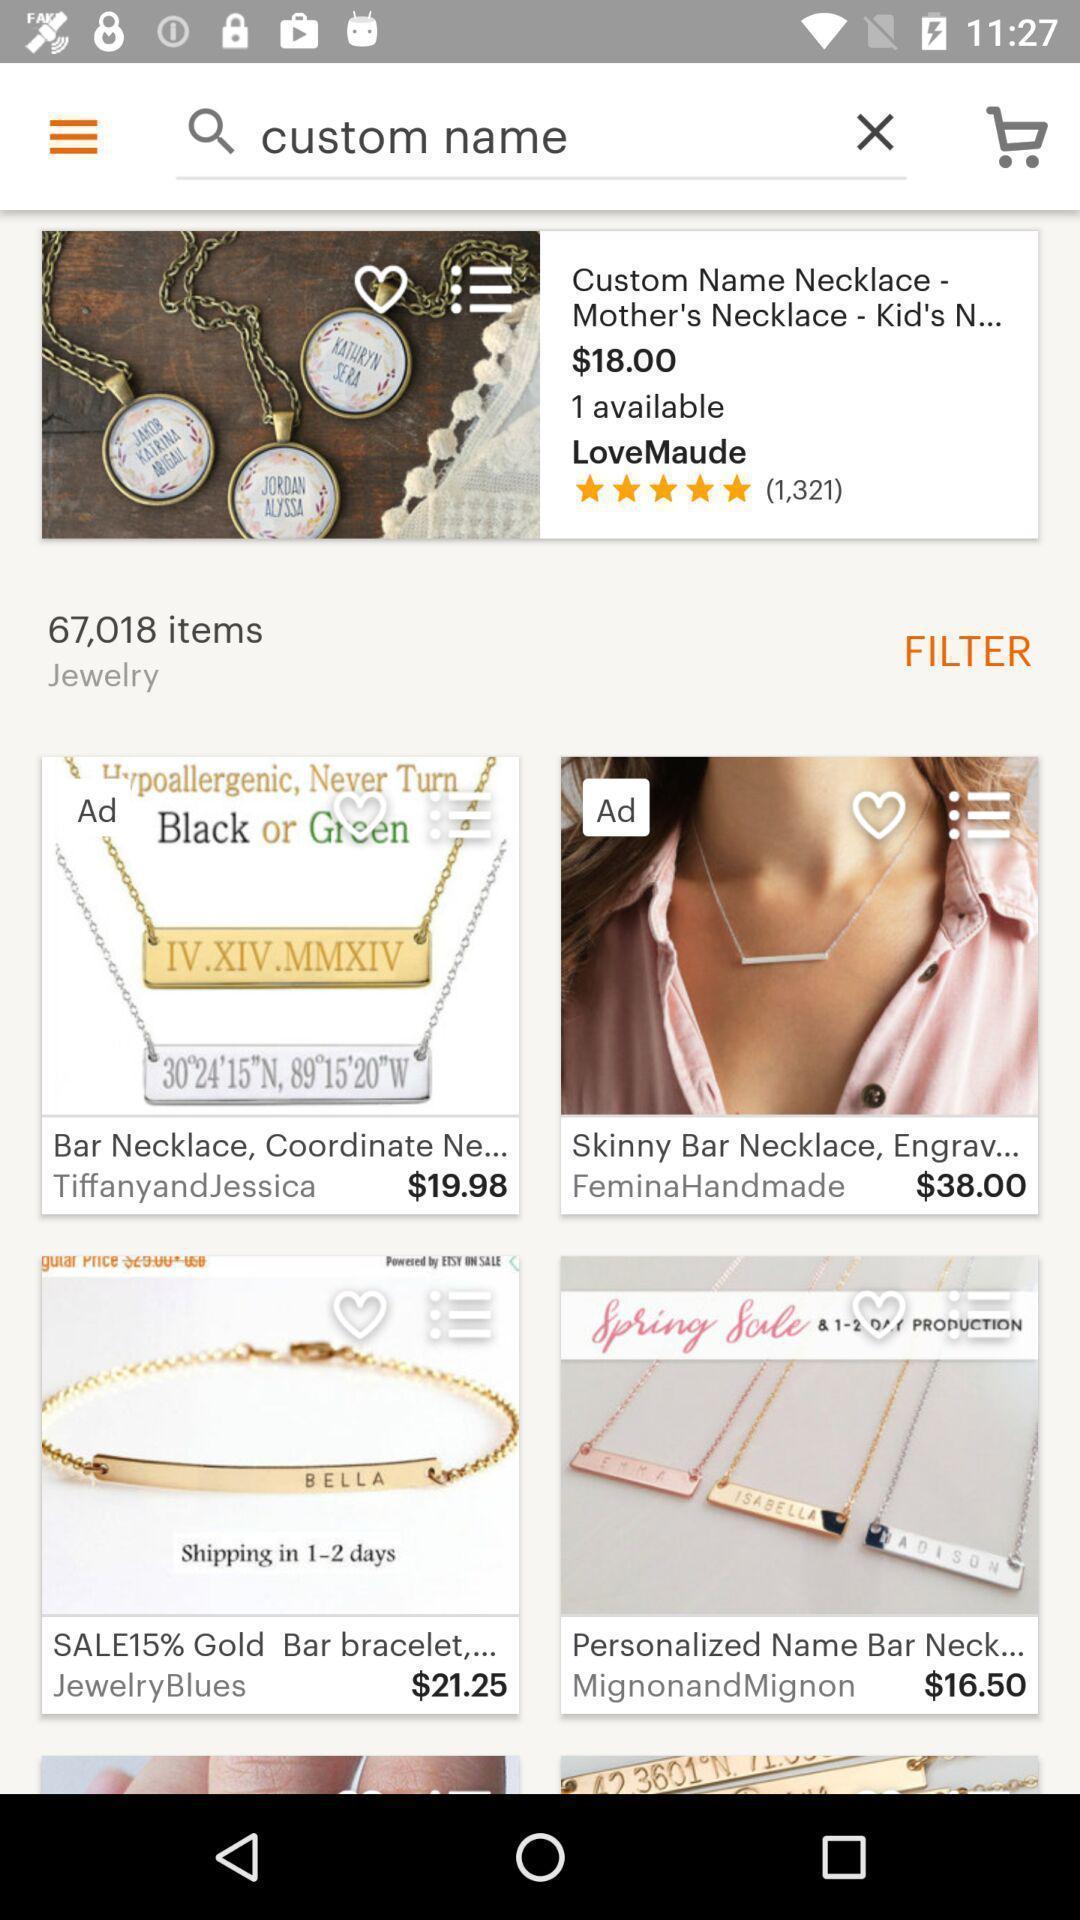Describe this image in words. Screen showing custom names of an item. 